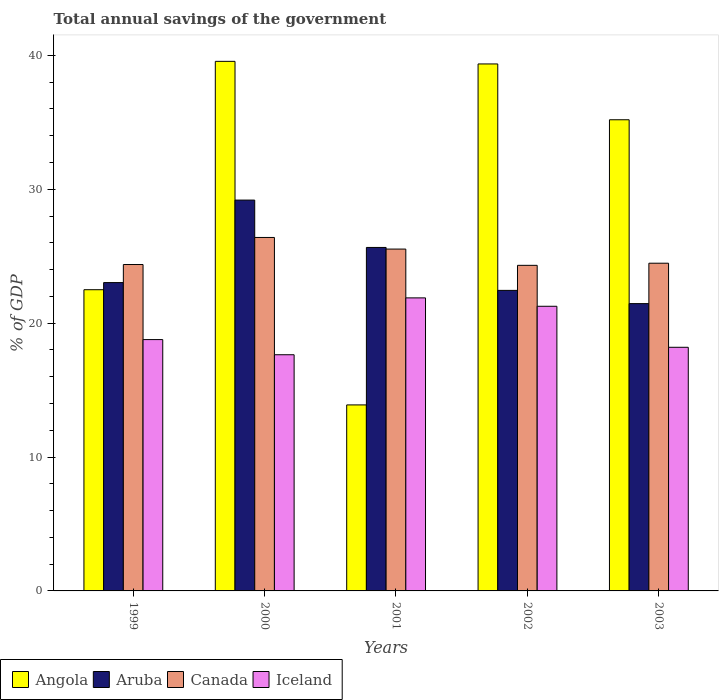How many different coloured bars are there?
Give a very brief answer. 4. How many groups of bars are there?
Give a very brief answer. 5. Are the number of bars on each tick of the X-axis equal?
Your answer should be very brief. Yes. What is the total annual savings of the government in Canada in 2002?
Offer a very short reply. 24.32. Across all years, what is the maximum total annual savings of the government in Iceland?
Your response must be concise. 21.89. Across all years, what is the minimum total annual savings of the government in Canada?
Your answer should be compact. 24.32. In which year was the total annual savings of the government in Canada maximum?
Your response must be concise. 2000. What is the total total annual savings of the government in Canada in the graph?
Your answer should be compact. 125.11. What is the difference between the total annual savings of the government in Aruba in 1999 and that in 2003?
Give a very brief answer. 1.57. What is the difference between the total annual savings of the government in Canada in 2001 and the total annual savings of the government in Aruba in 1999?
Offer a very short reply. 2.5. What is the average total annual savings of the government in Angola per year?
Your answer should be compact. 30.1. In the year 2003, what is the difference between the total annual savings of the government in Canada and total annual savings of the government in Angola?
Keep it short and to the point. -10.71. In how many years, is the total annual savings of the government in Aruba greater than 26 %?
Offer a very short reply. 1. What is the ratio of the total annual savings of the government in Aruba in 2000 to that in 2002?
Keep it short and to the point. 1.3. Is the total annual savings of the government in Aruba in 1999 less than that in 2002?
Your answer should be very brief. No. What is the difference between the highest and the second highest total annual savings of the government in Iceland?
Make the answer very short. 0.63. What is the difference between the highest and the lowest total annual savings of the government in Angola?
Ensure brevity in your answer.  25.66. In how many years, is the total annual savings of the government in Angola greater than the average total annual savings of the government in Angola taken over all years?
Your answer should be compact. 3. Is it the case that in every year, the sum of the total annual savings of the government in Angola and total annual savings of the government in Aruba is greater than the sum of total annual savings of the government in Iceland and total annual savings of the government in Canada?
Offer a very short reply. No. What does the 1st bar from the left in 2002 represents?
Your response must be concise. Angola. What does the 4th bar from the right in 2001 represents?
Give a very brief answer. Angola. Are all the bars in the graph horizontal?
Keep it short and to the point. No. Does the graph contain any zero values?
Ensure brevity in your answer.  No. Does the graph contain grids?
Ensure brevity in your answer.  No. How many legend labels are there?
Offer a very short reply. 4. What is the title of the graph?
Your response must be concise. Total annual savings of the government. Does "Switzerland" appear as one of the legend labels in the graph?
Give a very brief answer. No. What is the label or title of the X-axis?
Give a very brief answer. Years. What is the label or title of the Y-axis?
Provide a short and direct response. % of GDP. What is the % of GDP of Angola in 1999?
Make the answer very short. 22.5. What is the % of GDP in Aruba in 1999?
Provide a short and direct response. 23.03. What is the % of GDP in Canada in 1999?
Offer a terse response. 24.38. What is the % of GDP in Iceland in 1999?
Your answer should be very brief. 18.77. What is the % of GDP in Angola in 2000?
Ensure brevity in your answer.  39.56. What is the % of GDP in Aruba in 2000?
Offer a very short reply. 29.19. What is the % of GDP in Canada in 2000?
Your answer should be very brief. 26.4. What is the % of GDP in Iceland in 2000?
Your answer should be compact. 17.64. What is the % of GDP in Angola in 2001?
Provide a succinct answer. 13.89. What is the % of GDP of Aruba in 2001?
Give a very brief answer. 25.66. What is the % of GDP in Canada in 2001?
Ensure brevity in your answer.  25.53. What is the % of GDP of Iceland in 2001?
Offer a terse response. 21.89. What is the % of GDP of Angola in 2002?
Your answer should be compact. 39.36. What is the % of GDP in Aruba in 2002?
Provide a short and direct response. 22.45. What is the % of GDP in Canada in 2002?
Your response must be concise. 24.32. What is the % of GDP of Iceland in 2002?
Offer a terse response. 21.26. What is the % of GDP of Angola in 2003?
Ensure brevity in your answer.  35.19. What is the % of GDP of Aruba in 2003?
Offer a very short reply. 21.46. What is the % of GDP of Canada in 2003?
Keep it short and to the point. 24.48. What is the % of GDP in Iceland in 2003?
Your answer should be very brief. 18.2. Across all years, what is the maximum % of GDP in Angola?
Give a very brief answer. 39.56. Across all years, what is the maximum % of GDP in Aruba?
Your answer should be compact. 29.19. Across all years, what is the maximum % of GDP in Canada?
Ensure brevity in your answer.  26.4. Across all years, what is the maximum % of GDP of Iceland?
Ensure brevity in your answer.  21.89. Across all years, what is the minimum % of GDP in Angola?
Your response must be concise. 13.89. Across all years, what is the minimum % of GDP of Aruba?
Your answer should be compact. 21.46. Across all years, what is the minimum % of GDP of Canada?
Your answer should be very brief. 24.32. Across all years, what is the minimum % of GDP of Iceland?
Your answer should be compact. 17.64. What is the total % of GDP of Angola in the graph?
Ensure brevity in your answer.  150.5. What is the total % of GDP of Aruba in the graph?
Make the answer very short. 121.79. What is the total % of GDP in Canada in the graph?
Your response must be concise. 125.11. What is the total % of GDP of Iceland in the graph?
Your answer should be compact. 97.76. What is the difference between the % of GDP of Angola in 1999 and that in 2000?
Your response must be concise. -17.06. What is the difference between the % of GDP of Aruba in 1999 and that in 2000?
Give a very brief answer. -6.16. What is the difference between the % of GDP in Canada in 1999 and that in 2000?
Make the answer very short. -2.02. What is the difference between the % of GDP of Iceland in 1999 and that in 2000?
Ensure brevity in your answer.  1.13. What is the difference between the % of GDP in Angola in 1999 and that in 2001?
Offer a very short reply. 8.61. What is the difference between the % of GDP in Aruba in 1999 and that in 2001?
Your response must be concise. -2.62. What is the difference between the % of GDP of Canada in 1999 and that in 2001?
Provide a short and direct response. -1.15. What is the difference between the % of GDP in Iceland in 1999 and that in 2001?
Keep it short and to the point. -3.11. What is the difference between the % of GDP of Angola in 1999 and that in 2002?
Your answer should be compact. -16.86. What is the difference between the % of GDP in Aruba in 1999 and that in 2002?
Your answer should be very brief. 0.58. What is the difference between the % of GDP of Iceland in 1999 and that in 2002?
Ensure brevity in your answer.  -2.49. What is the difference between the % of GDP of Angola in 1999 and that in 2003?
Make the answer very short. -12.69. What is the difference between the % of GDP in Aruba in 1999 and that in 2003?
Your response must be concise. 1.57. What is the difference between the % of GDP of Canada in 1999 and that in 2003?
Your answer should be very brief. -0.1. What is the difference between the % of GDP in Iceland in 1999 and that in 2003?
Your answer should be compact. 0.58. What is the difference between the % of GDP in Angola in 2000 and that in 2001?
Keep it short and to the point. 25.66. What is the difference between the % of GDP of Aruba in 2000 and that in 2001?
Give a very brief answer. 3.54. What is the difference between the % of GDP of Canada in 2000 and that in 2001?
Keep it short and to the point. 0.87. What is the difference between the % of GDP in Iceland in 2000 and that in 2001?
Keep it short and to the point. -4.25. What is the difference between the % of GDP in Angola in 2000 and that in 2002?
Ensure brevity in your answer.  0.19. What is the difference between the % of GDP in Aruba in 2000 and that in 2002?
Your answer should be compact. 6.74. What is the difference between the % of GDP in Canada in 2000 and that in 2002?
Provide a succinct answer. 2.08. What is the difference between the % of GDP of Iceland in 2000 and that in 2002?
Your answer should be very brief. -3.62. What is the difference between the % of GDP in Angola in 2000 and that in 2003?
Your answer should be compact. 4.36. What is the difference between the % of GDP in Aruba in 2000 and that in 2003?
Give a very brief answer. 7.73. What is the difference between the % of GDP of Canada in 2000 and that in 2003?
Make the answer very short. 1.92. What is the difference between the % of GDP in Iceland in 2000 and that in 2003?
Give a very brief answer. -0.56. What is the difference between the % of GDP of Angola in 2001 and that in 2002?
Your answer should be very brief. -25.47. What is the difference between the % of GDP of Aruba in 2001 and that in 2002?
Your response must be concise. 3.21. What is the difference between the % of GDP in Canada in 2001 and that in 2002?
Provide a short and direct response. 1.21. What is the difference between the % of GDP of Iceland in 2001 and that in 2002?
Offer a very short reply. 0.63. What is the difference between the % of GDP in Angola in 2001 and that in 2003?
Offer a terse response. -21.3. What is the difference between the % of GDP in Aruba in 2001 and that in 2003?
Your response must be concise. 4.2. What is the difference between the % of GDP of Canada in 2001 and that in 2003?
Make the answer very short. 1.06. What is the difference between the % of GDP of Iceland in 2001 and that in 2003?
Offer a terse response. 3.69. What is the difference between the % of GDP in Angola in 2002 and that in 2003?
Give a very brief answer. 4.17. What is the difference between the % of GDP of Aruba in 2002 and that in 2003?
Offer a terse response. 0.99. What is the difference between the % of GDP in Canada in 2002 and that in 2003?
Give a very brief answer. -0.16. What is the difference between the % of GDP in Iceland in 2002 and that in 2003?
Your answer should be very brief. 3.06. What is the difference between the % of GDP in Angola in 1999 and the % of GDP in Aruba in 2000?
Your answer should be very brief. -6.69. What is the difference between the % of GDP in Angola in 1999 and the % of GDP in Canada in 2000?
Your answer should be compact. -3.9. What is the difference between the % of GDP in Angola in 1999 and the % of GDP in Iceland in 2000?
Offer a terse response. 4.86. What is the difference between the % of GDP in Aruba in 1999 and the % of GDP in Canada in 2000?
Your answer should be compact. -3.37. What is the difference between the % of GDP in Aruba in 1999 and the % of GDP in Iceland in 2000?
Your response must be concise. 5.39. What is the difference between the % of GDP of Canada in 1999 and the % of GDP of Iceland in 2000?
Ensure brevity in your answer.  6.74. What is the difference between the % of GDP of Angola in 1999 and the % of GDP of Aruba in 2001?
Offer a terse response. -3.16. What is the difference between the % of GDP in Angola in 1999 and the % of GDP in Canada in 2001?
Offer a very short reply. -3.03. What is the difference between the % of GDP in Angola in 1999 and the % of GDP in Iceland in 2001?
Your answer should be compact. 0.61. What is the difference between the % of GDP of Aruba in 1999 and the % of GDP of Canada in 2001?
Ensure brevity in your answer.  -2.5. What is the difference between the % of GDP in Aruba in 1999 and the % of GDP in Iceland in 2001?
Keep it short and to the point. 1.14. What is the difference between the % of GDP in Canada in 1999 and the % of GDP in Iceland in 2001?
Ensure brevity in your answer.  2.49. What is the difference between the % of GDP in Angola in 1999 and the % of GDP in Aruba in 2002?
Keep it short and to the point. 0.05. What is the difference between the % of GDP in Angola in 1999 and the % of GDP in Canada in 2002?
Offer a very short reply. -1.82. What is the difference between the % of GDP in Angola in 1999 and the % of GDP in Iceland in 2002?
Your response must be concise. 1.24. What is the difference between the % of GDP in Aruba in 1999 and the % of GDP in Canada in 2002?
Your answer should be compact. -1.29. What is the difference between the % of GDP in Aruba in 1999 and the % of GDP in Iceland in 2002?
Ensure brevity in your answer.  1.77. What is the difference between the % of GDP in Canada in 1999 and the % of GDP in Iceland in 2002?
Ensure brevity in your answer.  3.12. What is the difference between the % of GDP in Angola in 1999 and the % of GDP in Aruba in 2003?
Make the answer very short. 1.04. What is the difference between the % of GDP of Angola in 1999 and the % of GDP of Canada in 2003?
Give a very brief answer. -1.98. What is the difference between the % of GDP of Angola in 1999 and the % of GDP of Iceland in 2003?
Ensure brevity in your answer.  4.3. What is the difference between the % of GDP in Aruba in 1999 and the % of GDP in Canada in 2003?
Give a very brief answer. -1.45. What is the difference between the % of GDP in Aruba in 1999 and the % of GDP in Iceland in 2003?
Ensure brevity in your answer.  4.83. What is the difference between the % of GDP in Canada in 1999 and the % of GDP in Iceland in 2003?
Provide a short and direct response. 6.18. What is the difference between the % of GDP of Angola in 2000 and the % of GDP of Aruba in 2001?
Ensure brevity in your answer.  13.9. What is the difference between the % of GDP in Angola in 2000 and the % of GDP in Canada in 2001?
Provide a succinct answer. 14.02. What is the difference between the % of GDP in Angola in 2000 and the % of GDP in Iceland in 2001?
Give a very brief answer. 17.67. What is the difference between the % of GDP of Aruba in 2000 and the % of GDP of Canada in 2001?
Offer a terse response. 3.66. What is the difference between the % of GDP of Aruba in 2000 and the % of GDP of Iceland in 2001?
Your answer should be very brief. 7.31. What is the difference between the % of GDP in Canada in 2000 and the % of GDP in Iceland in 2001?
Make the answer very short. 4.51. What is the difference between the % of GDP of Angola in 2000 and the % of GDP of Aruba in 2002?
Make the answer very short. 17.11. What is the difference between the % of GDP in Angola in 2000 and the % of GDP in Canada in 2002?
Make the answer very short. 15.24. What is the difference between the % of GDP of Angola in 2000 and the % of GDP of Iceland in 2002?
Give a very brief answer. 18.29. What is the difference between the % of GDP in Aruba in 2000 and the % of GDP in Canada in 2002?
Give a very brief answer. 4.87. What is the difference between the % of GDP of Aruba in 2000 and the % of GDP of Iceland in 2002?
Provide a short and direct response. 7.93. What is the difference between the % of GDP in Canada in 2000 and the % of GDP in Iceland in 2002?
Make the answer very short. 5.14. What is the difference between the % of GDP in Angola in 2000 and the % of GDP in Aruba in 2003?
Offer a terse response. 18.09. What is the difference between the % of GDP of Angola in 2000 and the % of GDP of Canada in 2003?
Your response must be concise. 15.08. What is the difference between the % of GDP of Angola in 2000 and the % of GDP of Iceland in 2003?
Your response must be concise. 21.36. What is the difference between the % of GDP of Aruba in 2000 and the % of GDP of Canada in 2003?
Ensure brevity in your answer.  4.72. What is the difference between the % of GDP of Aruba in 2000 and the % of GDP of Iceland in 2003?
Give a very brief answer. 11. What is the difference between the % of GDP of Canada in 2000 and the % of GDP of Iceland in 2003?
Offer a terse response. 8.2. What is the difference between the % of GDP of Angola in 2001 and the % of GDP of Aruba in 2002?
Keep it short and to the point. -8.56. What is the difference between the % of GDP in Angola in 2001 and the % of GDP in Canada in 2002?
Provide a short and direct response. -10.43. What is the difference between the % of GDP in Angola in 2001 and the % of GDP in Iceland in 2002?
Keep it short and to the point. -7.37. What is the difference between the % of GDP of Aruba in 2001 and the % of GDP of Canada in 2002?
Offer a very short reply. 1.34. What is the difference between the % of GDP of Aruba in 2001 and the % of GDP of Iceland in 2002?
Keep it short and to the point. 4.39. What is the difference between the % of GDP in Canada in 2001 and the % of GDP in Iceland in 2002?
Your response must be concise. 4.27. What is the difference between the % of GDP in Angola in 2001 and the % of GDP in Aruba in 2003?
Ensure brevity in your answer.  -7.57. What is the difference between the % of GDP of Angola in 2001 and the % of GDP of Canada in 2003?
Your answer should be very brief. -10.58. What is the difference between the % of GDP in Angola in 2001 and the % of GDP in Iceland in 2003?
Provide a short and direct response. -4.3. What is the difference between the % of GDP of Aruba in 2001 and the % of GDP of Canada in 2003?
Keep it short and to the point. 1.18. What is the difference between the % of GDP in Aruba in 2001 and the % of GDP in Iceland in 2003?
Your response must be concise. 7.46. What is the difference between the % of GDP in Canada in 2001 and the % of GDP in Iceland in 2003?
Make the answer very short. 7.34. What is the difference between the % of GDP of Angola in 2002 and the % of GDP of Aruba in 2003?
Provide a succinct answer. 17.9. What is the difference between the % of GDP of Angola in 2002 and the % of GDP of Canada in 2003?
Offer a very short reply. 14.88. What is the difference between the % of GDP of Angola in 2002 and the % of GDP of Iceland in 2003?
Ensure brevity in your answer.  21.16. What is the difference between the % of GDP in Aruba in 2002 and the % of GDP in Canada in 2003?
Offer a very short reply. -2.03. What is the difference between the % of GDP of Aruba in 2002 and the % of GDP of Iceland in 2003?
Offer a very short reply. 4.25. What is the difference between the % of GDP in Canada in 2002 and the % of GDP in Iceland in 2003?
Your response must be concise. 6.12. What is the average % of GDP of Angola per year?
Ensure brevity in your answer.  30.1. What is the average % of GDP of Aruba per year?
Provide a succinct answer. 24.36. What is the average % of GDP of Canada per year?
Your answer should be very brief. 25.02. What is the average % of GDP in Iceland per year?
Your answer should be compact. 19.55. In the year 1999, what is the difference between the % of GDP of Angola and % of GDP of Aruba?
Offer a terse response. -0.53. In the year 1999, what is the difference between the % of GDP in Angola and % of GDP in Canada?
Provide a short and direct response. -1.88. In the year 1999, what is the difference between the % of GDP in Angola and % of GDP in Iceland?
Provide a short and direct response. 3.73. In the year 1999, what is the difference between the % of GDP in Aruba and % of GDP in Canada?
Your answer should be compact. -1.35. In the year 1999, what is the difference between the % of GDP in Aruba and % of GDP in Iceland?
Make the answer very short. 4.26. In the year 1999, what is the difference between the % of GDP of Canada and % of GDP of Iceland?
Your answer should be very brief. 5.61. In the year 2000, what is the difference between the % of GDP of Angola and % of GDP of Aruba?
Ensure brevity in your answer.  10.36. In the year 2000, what is the difference between the % of GDP of Angola and % of GDP of Canada?
Ensure brevity in your answer.  13.15. In the year 2000, what is the difference between the % of GDP in Angola and % of GDP in Iceland?
Provide a short and direct response. 21.91. In the year 2000, what is the difference between the % of GDP of Aruba and % of GDP of Canada?
Your answer should be very brief. 2.79. In the year 2000, what is the difference between the % of GDP of Aruba and % of GDP of Iceland?
Provide a succinct answer. 11.55. In the year 2000, what is the difference between the % of GDP of Canada and % of GDP of Iceland?
Your response must be concise. 8.76. In the year 2001, what is the difference between the % of GDP in Angola and % of GDP in Aruba?
Ensure brevity in your answer.  -11.76. In the year 2001, what is the difference between the % of GDP of Angola and % of GDP of Canada?
Your answer should be very brief. -11.64. In the year 2001, what is the difference between the % of GDP of Angola and % of GDP of Iceland?
Provide a succinct answer. -7.99. In the year 2001, what is the difference between the % of GDP in Aruba and % of GDP in Canada?
Give a very brief answer. 0.12. In the year 2001, what is the difference between the % of GDP of Aruba and % of GDP of Iceland?
Your answer should be very brief. 3.77. In the year 2001, what is the difference between the % of GDP of Canada and % of GDP of Iceland?
Your response must be concise. 3.65. In the year 2002, what is the difference between the % of GDP of Angola and % of GDP of Aruba?
Provide a short and direct response. 16.91. In the year 2002, what is the difference between the % of GDP in Angola and % of GDP in Canada?
Offer a terse response. 15.04. In the year 2002, what is the difference between the % of GDP of Angola and % of GDP of Iceland?
Your response must be concise. 18.1. In the year 2002, what is the difference between the % of GDP in Aruba and % of GDP in Canada?
Keep it short and to the point. -1.87. In the year 2002, what is the difference between the % of GDP of Aruba and % of GDP of Iceland?
Ensure brevity in your answer.  1.19. In the year 2002, what is the difference between the % of GDP of Canada and % of GDP of Iceland?
Ensure brevity in your answer.  3.06. In the year 2003, what is the difference between the % of GDP of Angola and % of GDP of Aruba?
Provide a succinct answer. 13.73. In the year 2003, what is the difference between the % of GDP in Angola and % of GDP in Canada?
Make the answer very short. 10.71. In the year 2003, what is the difference between the % of GDP of Angola and % of GDP of Iceland?
Give a very brief answer. 16.99. In the year 2003, what is the difference between the % of GDP of Aruba and % of GDP of Canada?
Your response must be concise. -3.02. In the year 2003, what is the difference between the % of GDP of Aruba and % of GDP of Iceland?
Keep it short and to the point. 3.26. In the year 2003, what is the difference between the % of GDP of Canada and % of GDP of Iceland?
Make the answer very short. 6.28. What is the ratio of the % of GDP of Angola in 1999 to that in 2000?
Keep it short and to the point. 0.57. What is the ratio of the % of GDP in Aruba in 1999 to that in 2000?
Ensure brevity in your answer.  0.79. What is the ratio of the % of GDP of Canada in 1999 to that in 2000?
Keep it short and to the point. 0.92. What is the ratio of the % of GDP of Iceland in 1999 to that in 2000?
Provide a short and direct response. 1.06. What is the ratio of the % of GDP in Angola in 1999 to that in 2001?
Provide a succinct answer. 1.62. What is the ratio of the % of GDP of Aruba in 1999 to that in 2001?
Offer a very short reply. 0.9. What is the ratio of the % of GDP in Canada in 1999 to that in 2001?
Offer a very short reply. 0.95. What is the ratio of the % of GDP of Iceland in 1999 to that in 2001?
Offer a terse response. 0.86. What is the ratio of the % of GDP in Angola in 1999 to that in 2002?
Offer a terse response. 0.57. What is the ratio of the % of GDP in Aruba in 1999 to that in 2002?
Your response must be concise. 1.03. What is the ratio of the % of GDP in Canada in 1999 to that in 2002?
Your answer should be very brief. 1. What is the ratio of the % of GDP in Iceland in 1999 to that in 2002?
Your response must be concise. 0.88. What is the ratio of the % of GDP in Angola in 1999 to that in 2003?
Ensure brevity in your answer.  0.64. What is the ratio of the % of GDP in Aruba in 1999 to that in 2003?
Provide a succinct answer. 1.07. What is the ratio of the % of GDP in Canada in 1999 to that in 2003?
Your answer should be compact. 1. What is the ratio of the % of GDP in Iceland in 1999 to that in 2003?
Your response must be concise. 1.03. What is the ratio of the % of GDP of Angola in 2000 to that in 2001?
Offer a very short reply. 2.85. What is the ratio of the % of GDP of Aruba in 2000 to that in 2001?
Your answer should be very brief. 1.14. What is the ratio of the % of GDP of Canada in 2000 to that in 2001?
Give a very brief answer. 1.03. What is the ratio of the % of GDP in Iceland in 2000 to that in 2001?
Keep it short and to the point. 0.81. What is the ratio of the % of GDP in Aruba in 2000 to that in 2002?
Give a very brief answer. 1.3. What is the ratio of the % of GDP of Canada in 2000 to that in 2002?
Keep it short and to the point. 1.09. What is the ratio of the % of GDP of Iceland in 2000 to that in 2002?
Make the answer very short. 0.83. What is the ratio of the % of GDP in Angola in 2000 to that in 2003?
Offer a terse response. 1.12. What is the ratio of the % of GDP of Aruba in 2000 to that in 2003?
Your answer should be compact. 1.36. What is the ratio of the % of GDP of Canada in 2000 to that in 2003?
Give a very brief answer. 1.08. What is the ratio of the % of GDP of Iceland in 2000 to that in 2003?
Your answer should be very brief. 0.97. What is the ratio of the % of GDP of Angola in 2001 to that in 2002?
Provide a succinct answer. 0.35. What is the ratio of the % of GDP of Canada in 2001 to that in 2002?
Offer a terse response. 1.05. What is the ratio of the % of GDP of Iceland in 2001 to that in 2002?
Make the answer very short. 1.03. What is the ratio of the % of GDP of Angola in 2001 to that in 2003?
Give a very brief answer. 0.39. What is the ratio of the % of GDP in Aruba in 2001 to that in 2003?
Offer a terse response. 1.2. What is the ratio of the % of GDP in Canada in 2001 to that in 2003?
Offer a terse response. 1.04. What is the ratio of the % of GDP of Iceland in 2001 to that in 2003?
Provide a succinct answer. 1.2. What is the ratio of the % of GDP in Angola in 2002 to that in 2003?
Your answer should be compact. 1.12. What is the ratio of the % of GDP of Aruba in 2002 to that in 2003?
Your answer should be very brief. 1.05. What is the ratio of the % of GDP in Iceland in 2002 to that in 2003?
Ensure brevity in your answer.  1.17. What is the difference between the highest and the second highest % of GDP of Angola?
Provide a succinct answer. 0.19. What is the difference between the highest and the second highest % of GDP of Aruba?
Your answer should be very brief. 3.54. What is the difference between the highest and the second highest % of GDP in Canada?
Your response must be concise. 0.87. What is the difference between the highest and the second highest % of GDP in Iceland?
Offer a very short reply. 0.63. What is the difference between the highest and the lowest % of GDP in Angola?
Your answer should be very brief. 25.66. What is the difference between the highest and the lowest % of GDP in Aruba?
Keep it short and to the point. 7.73. What is the difference between the highest and the lowest % of GDP of Canada?
Your answer should be compact. 2.08. What is the difference between the highest and the lowest % of GDP of Iceland?
Ensure brevity in your answer.  4.25. 